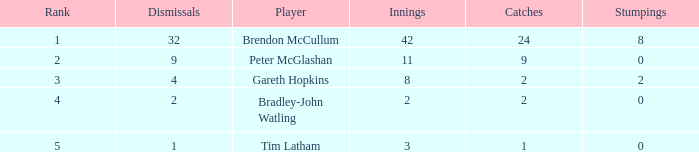Itemize the positions of all terminations with a value of 4 3.0. 